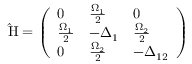Convert formula to latex. <formula><loc_0><loc_0><loc_500><loc_500>\hat { H } = \left ( \begin{array} { l l l } { 0 } & { \frac { \Omega _ { 1 } } { 2 } } & { 0 } \\ { \frac { \Omega _ { 1 } } { 2 } } & { - \Delta _ { 1 } } & { \frac { \Omega _ { 2 } } { 2 } } \\ { 0 } & { \frac { \Omega _ { 2 } } { 2 } } & { - \Delta _ { 1 2 } } \end{array} \right )</formula> 